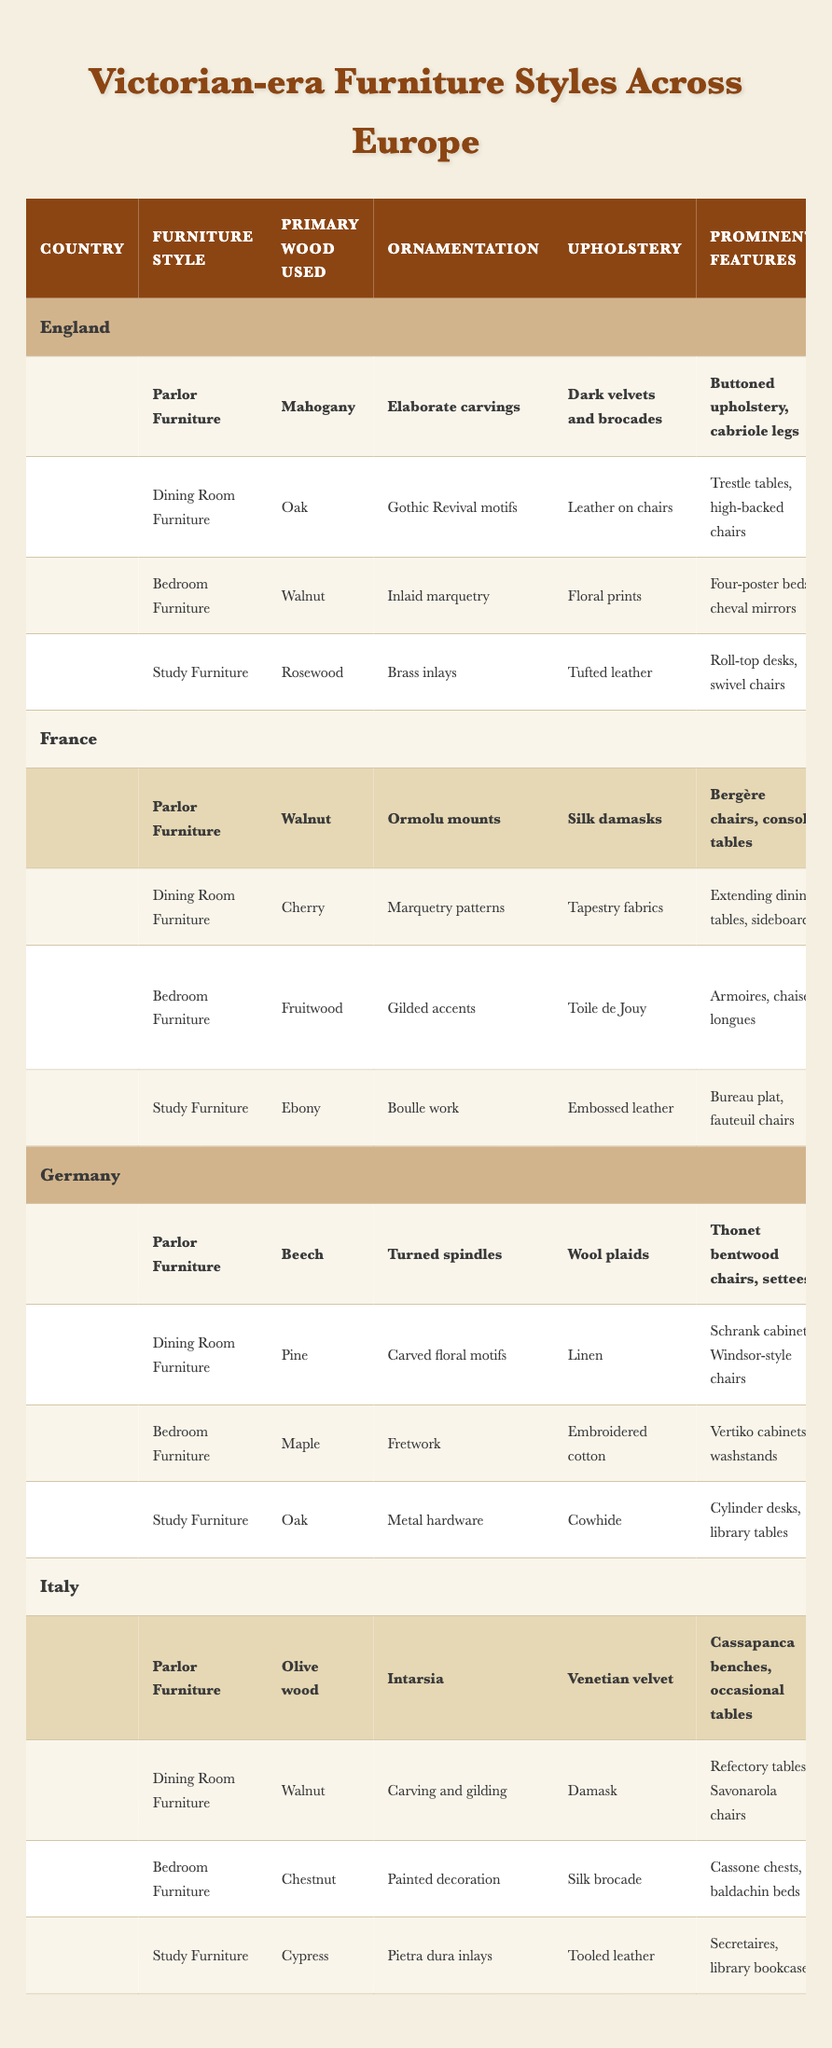What type of wood is primarily used for Parlor Furniture in France? According to the data in the table, the primary wood used for Parlor Furniture in France is Walnut.
Answer: Walnut Which country has the highest variation of wood types used in Bedroom Furniture? By examining the table, each country uses a different type of wood for Bedroom Furniture: England uses Walnut, France uses Fruitwood, Germany uses Maple, and Italy uses Chestnut. Since there are four different wood types from the four countries, they all have variation, but no country has more than one type. Thus, this question cannot identify one specific country.
Answer: All countries have variation Is it true that all countries use Upholstery made of silk for their Parlor Furniture? The table indicates the Upholstery materials for each country: England uses dark velvets and brocades, France uses silk damasks, Germany uses wool plaids, and Italy uses Venetian velvet. Since not all countries use silk, the statement is false.
Answer: False What are the prominent features of Dining Room Furniture in Germany? From the table, the prominent features of Dining Room Furniture in Germany are Schrank cabinets and Windsor-style chairs.
Answer: Schrank cabinets, Windsor-style chairs Which country features Intarsia as an ornamentation style for its Parlor Furniture? Referring to the data, Italy features Intarsia as the ornamentation style for its Parlor Furniture.
Answer: Italy How many countries primarily use walnut in their bedroom furniture? The countries that use Walnut for Bedroom Furniture are England (Walnut) and Italy (Chestnut). Thus, only one country primarily uses Walnut.
Answer: One country Which country has the most significant contrast in Upholstery materials between its Parlor and Study Furniture? In the table, for England, the Parlor Furniture has dark velvets and brocades while the Study Furniture has tufted leather; for France, Parlor Furniture uses silk damasks and Study Furniture uses embossed leather; for Germany, Parlor Furniture uses wool plaids and Study Furniture uses cowhide; for Italy, Parlor Furniture uses Venetian velvet and Study Furniture uses tooled leather. All these represent considerable differences, but Italy shows the most contrast in terms of texture and style (from fabric to leather) between the two types.
Answer: Italy Do all countries’ Study Furniture use the same type of wood? From the table, England uses Rosewood, France uses Ebony, Germany uses Oak, and Italy uses Cypress. Since they all use different types of wood, the statement is false.
Answer: False Which country employs the most complex ornamentation in its furniture styles? By analyzing the table, France utilizes more complex ornamentation styles such as ormolu mounts, marquetry patterns, gilded accents, and Boulle work. In contrast, other countries have simpler ornamentation. So, France is identified as employing the most complex ornamentation in their furniture styles.
Answer: France 